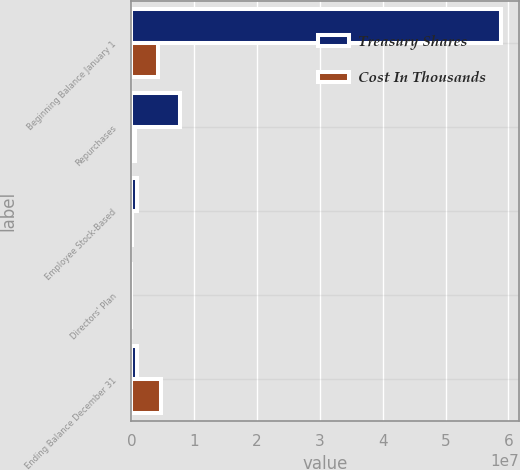Convert chart. <chart><loc_0><loc_0><loc_500><loc_500><stacked_bar_chart><ecel><fcel>Beginning Balance January 1<fcel>Repurchases<fcel>Employee Stock-Based<fcel>Directors' Plan<fcel>Ending Balance December 31<nl><fcel>Treasury Shares<fcel>5.88155e+07<fcel>7.68e+06<fcel>856390<fcel>4548<fcel>856390<nl><fcel>Cost In Thousands<fcel>4.17521e+06<fcel>613125<fcel>60846<fcel>326<fcel>4.72717e+06<nl></chart> 